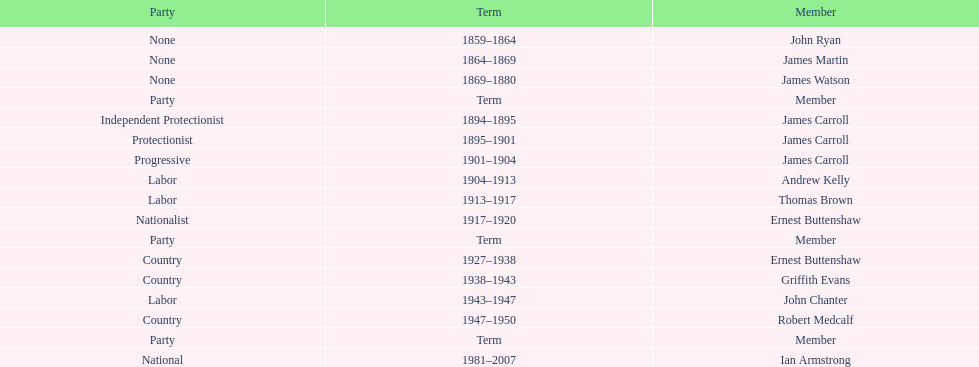How many years of service do the members of the second incarnation have combined? 26. 